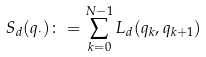Convert formula to latex. <formula><loc_0><loc_0><loc_500><loc_500>S _ { d } ( q _ { \cdot } ) \colon = \sum _ { k = 0 } ^ { N - 1 } L _ { d } ( q _ { k } , q _ { k + 1 } )</formula> 